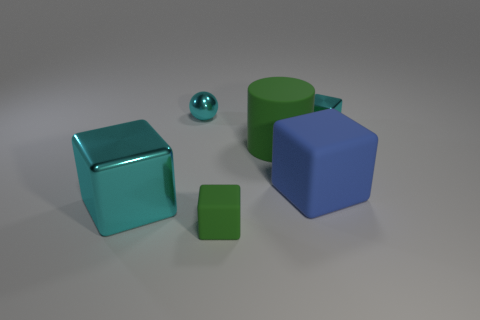What number of other things are the same size as the cyan metallic ball?
Provide a succinct answer. 2. Are there fewer small cyan rubber cylinders than metallic balls?
Ensure brevity in your answer.  Yes. The large cyan thing is what shape?
Provide a short and direct response. Cube. Is the color of the shiny object on the left side of the cyan ball the same as the metallic sphere?
Offer a terse response. Yes. What is the shape of the thing that is both to the right of the cyan metal ball and in front of the big blue object?
Make the answer very short. Cube. There is a rubber thing in front of the large cyan metallic object; what color is it?
Ensure brevity in your answer.  Green. Is there any other thing that is the same color as the big rubber cube?
Give a very brief answer. No. Does the green rubber block have the same size as the sphere?
Your answer should be compact. Yes. What is the size of the cyan object that is both behind the green rubber cylinder and left of the tiny cyan cube?
Keep it short and to the point. Small. How many spheres have the same material as the green block?
Provide a short and direct response. 0. 